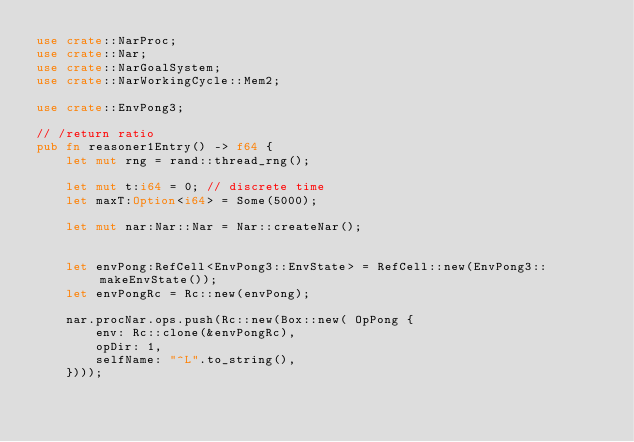<code> <loc_0><loc_0><loc_500><loc_500><_Rust_>use crate::NarProc;
use crate::Nar;
use crate::NarGoalSystem;
use crate::NarWorkingCycle::Mem2;

use crate::EnvPong3;

// /return ratio
pub fn reasoner1Entry() -> f64 {
    let mut rng = rand::thread_rng();

    let mut t:i64 = 0; // discrete time
    let maxT:Option<i64> = Some(5000);

    let mut nar:Nar::Nar = Nar::createNar();
    

    let envPong:RefCell<EnvPong3::EnvState> = RefCell::new(EnvPong3::makeEnvState());
    let envPongRc = Rc::new(envPong);

    nar.procNar.ops.push(Rc::new(Box::new( OpPong {
        env: Rc::clone(&envPongRc),
        opDir: 1,
        selfName: "^L".to_string(),
    })));
</code> 